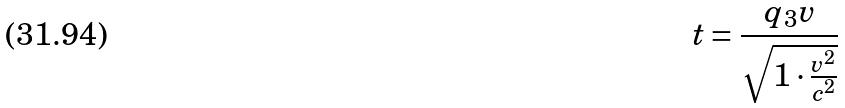<formula> <loc_0><loc_0><loc_500><loc_500>t = \frac { q _ { 3 } v } { \sqrt { 1 \cdot \frac { v ^ { 2 } } { c ^ { 2 } } } }</formula> 